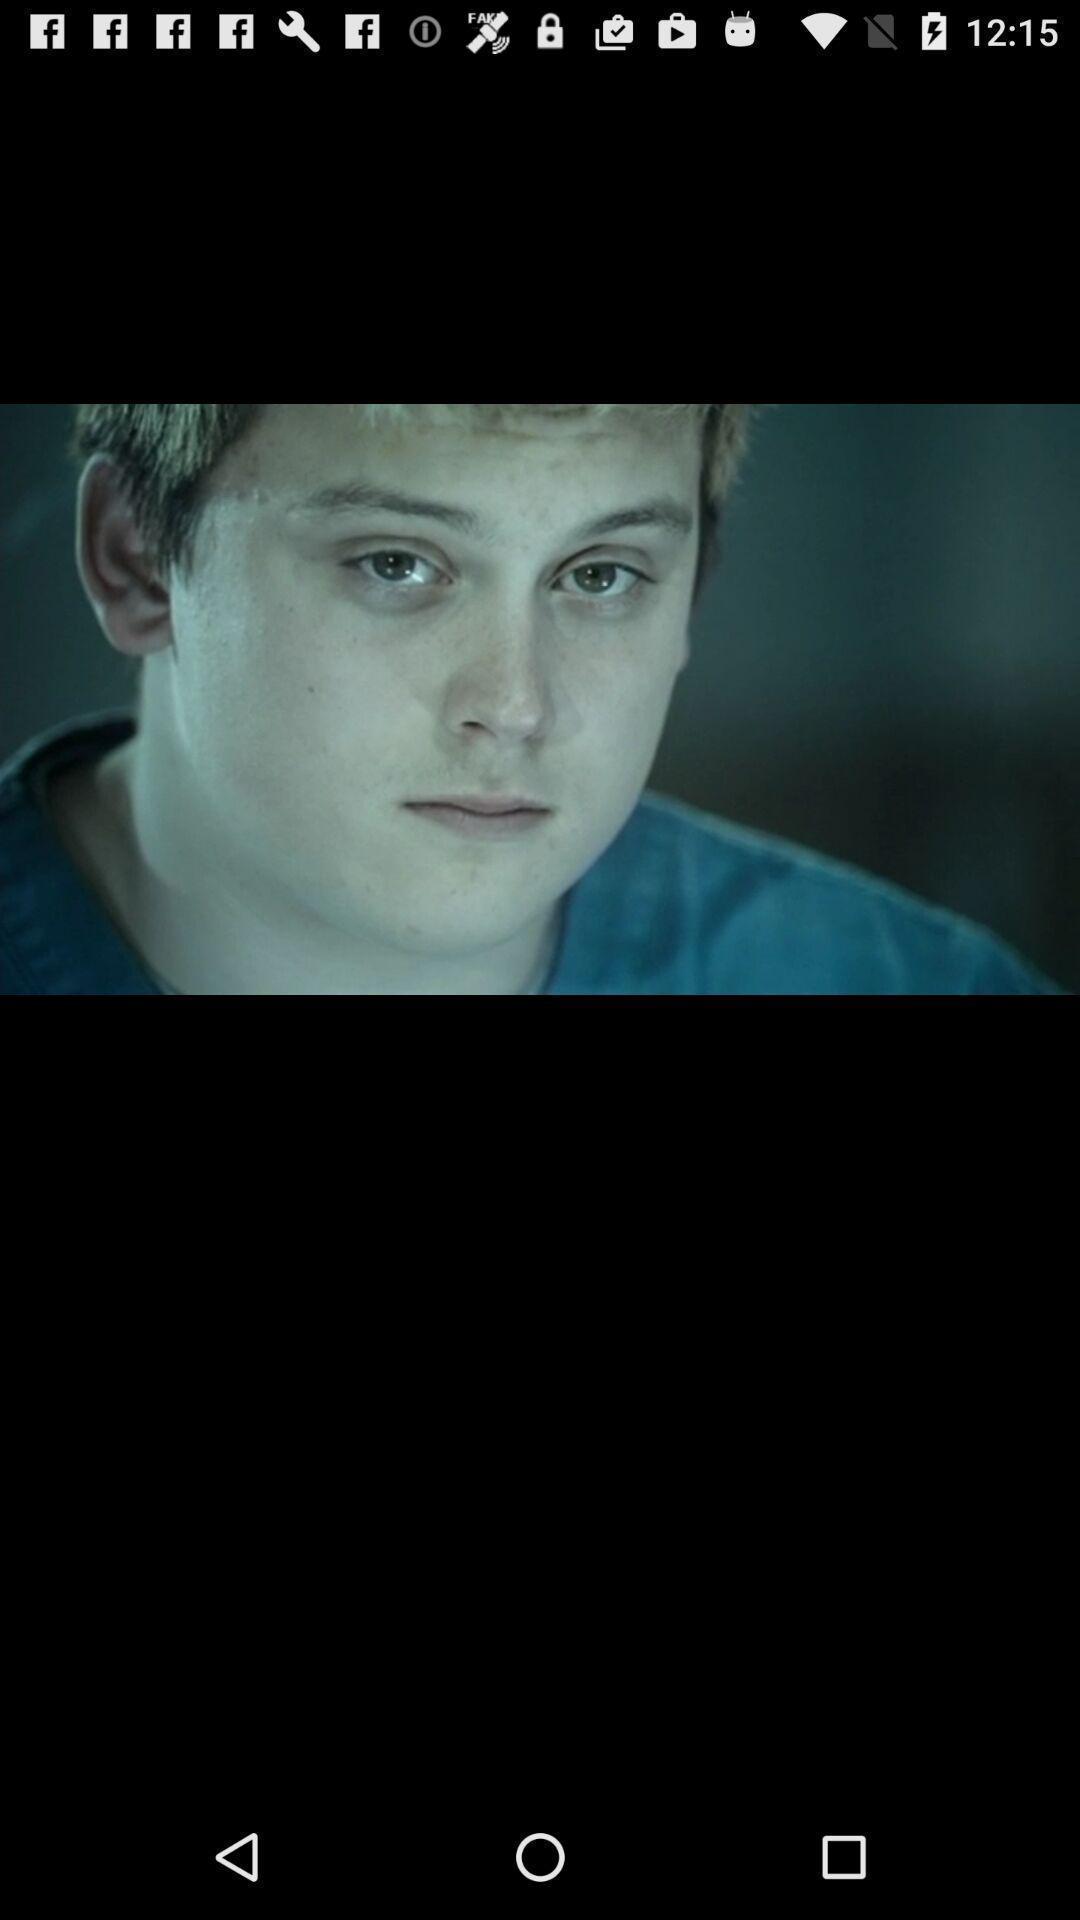What is the overall content of this screenshot? Screen displaying image of a boy. 